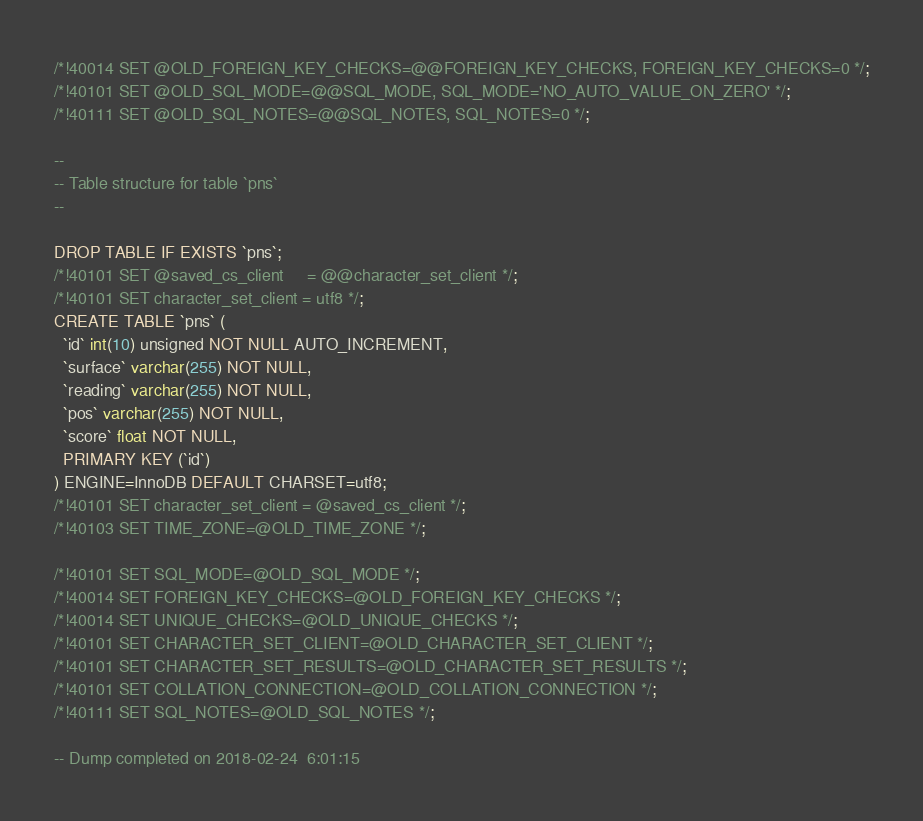Convert code to text. <code><loc_0><loc_0><loc_500><loc_500><_SQL_>/*!40014 SET @OLD_FOREIGN_KEY_CHECKS=@@FOREIGN_KEY_CHECKS, FOREIGN_KEY_CHECKS=0 */;
/*!40101 SET @OLD_SQL_MODE=@@SQL_MODE, SQL_MODE='NO_AUTO_VALUE_ON_ZERO' */;
/*!40111 SET @OLD_SQL_NOTES=@@SQL_NOTES, SQL_NOTES=0 */;

--
-- Table structure for table `pns`
--

DROP TABLE IF EXISTS `pns`;
/*!40101 SET @saved_cs_client     = @@character_set_client */;
/*!40101 SET character_set_client = utf8 */;
CREATE TABLE `pns` (
  `id` int(10) unsigned NOT NULL AUTO_INCREMENT,
  `surface` varchar(255) NOT NULL,
  `reading` varchar(255) NOT NULL,
  `pos` varchar(255) NOT NULL,
  `score` float NOT NULL,
  PRIMARY KEY (`id`)
) ENGINE=InnoDB DEFAULT CHARSET=utf8;
/*!40101 SET character_set_client = @saved_cs_client */;
/*!40103 SET TIME_ZONE=@OLD_TIME_ZONE */;

/*!40101 SET SQL_MODE=@OLD_SQL_MODE */;
/*!40014 SET FOREIGN_KEY_CHECKS=@OLD_FOREIGN_KEY_CHECKS */;
/*!40014 SET UNIQUE_CHECKS=@OLD_UNIQUE_CHECKS */;
/*!40101 SET CHARACTER_SET_CLIENT=@OLD_CHARACTER_SET_CLIENT */;
/*!40101 SET CHARACTER_SET_RESULTS=@OLD_CHARACTER_SET_RESULTS */;
/*!40101 SET COLLATION_CONNECTION=@OLD_COLLATION_CONNECTION */;
/*!40111 SET SQL_NOTES=@OLD_SQL_NOTES */;

-- Dump completed on 2018-02-24  6:01:15
</code> 